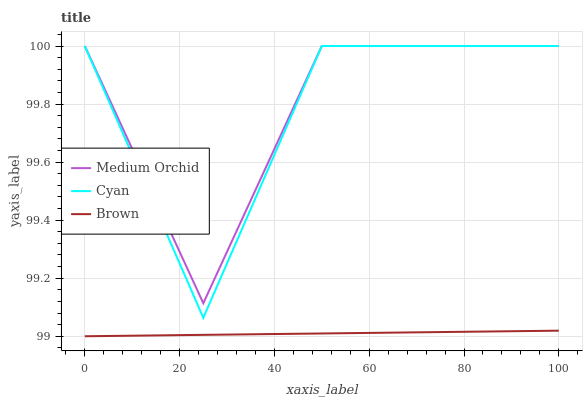Does Brown have the minimum area under the curve?
Answer yes or no. Yes. Does Medium Orchid have the maximum area under the curve?
Answer yes or no. Yes. Does Medium Orchid have the minimum area under the curve?
Answer yes or no. No. Does Brown have the maximum area under the curve?
Answer yes or no. No. Is Brown the smoothest?
Answer yes or no. Yes. Is Cyan the roughest?
Answer yes or no. Yes. Is Medium Orchid the smoothest?
Answer yes or no. No. Is Medium Orchid the roughest?
Answer yes or no. No. Does Medium Orchid have the lowest value?
Answer yes or no. No. Does Medium Orchid have the highest value?
Answer yes or no. Yes. Does Brown have the highest value?
Answer yes or no. No. Is Brown less than Cyan?
Answer yes or no. Yes. Is Cyan greater than Brown?
Answer yes or no. Yes. Does Brown intersect Cyan?
Answer yes or no. No. 